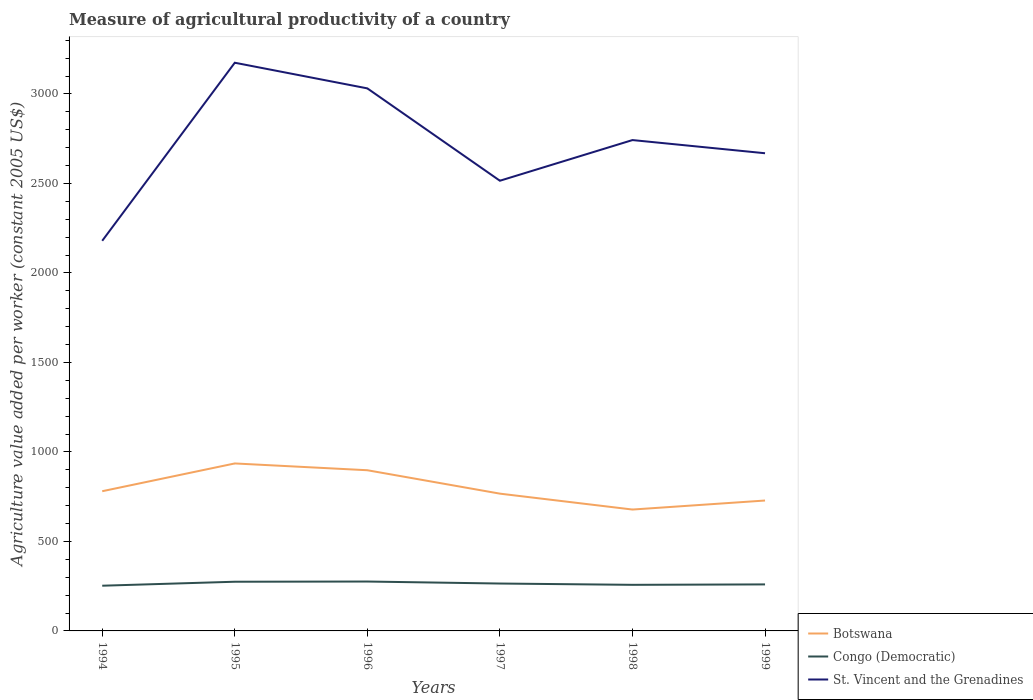Across all years, what is the maximum measure of agricultural productivity in St. Vincent and the Grenadines?
Your answer should be very brief. 2179.39. In which year was the measure of agricultural productivity in St. Vincent and the Grenadines maximum?
Keep it short and to the point. 1994. What is the total measure of agricultural productivity in St. Vincent and the Grenadines in the graph?
Your response must be concise. 288.8. What is the difference between the highest and the second highest measure of agricultural productivity in St. Vincent and the Grenadines?
Provide a short and direct response. 994.81. How many years are there in the graph?
Keep it short and to the point. 6. Does the graph contain grids?
Offer a terse response. No. How are the legend labels stacked?
Keep it short and to the point. Vertical. What is the title of the graph?
Your response must be concise. Measure of agricultural productivity of a country. What is the label or title of the X-axis?
Ensure brevity in your answer.  Years. What is the label or title of the Y-axis?
Make the answer very short. Agriculture value added per worker (constant 2005 US$). What is the Agriculture value added per worker (constant 2005 US$) of Botswana in 1994?
Your answer should be compact. 780.43. What is the Agriculture value added per worker (constant 2005 US$) of Congo (Democratic) in 1994?
Offer a very short reply. 252.57. What is the Agriculture value added per worker (constant 2005 US$) in St. Vincent and the Grenadines in 1994?
Provide a succinct answer. 2179.39. What is the Agriculture value added per worker (constant 2005 US$) of Botswana in 1995?
Ensure brevity in your answer.  935.6. What is the Agriculture value added per worker (constant 2005 US$) of Congo (Democratic) in 1995?
Your response must be concise. 274.79. What is the Agriculture value added per worker (constant 2005 US$) of St. Vincent and the Grenadines in 1995?
Your response must be concise. 3174.2. What is the Agriculture value added per worker (constant 2005 US$) of Botswana in 1996?
Offer a terse response. 897.7. What is the Agriculture value added per worker (constant 2005 US$) of Congo (Democratic) in 1996?
Provide a succinct answer. 275.92. What is the Agriculture value added per worker (constant 2005 US$) in St. Vincent and the Grenadines in 1996?
Your answer should be compact. 3030.91. What is the Agriculture value added per worker (constant 2005 US$) in Botswana in 1997?
Provide a short and direct response. 766.89. What is the Agriculture value added per worker (constant 2005 US$) in Congo (Democratic) in 1997?
Offer a very short reply. 264.74. What is the Agriculture value added per worker (constant 2005 US$) in St. Vincent and the Grenadines in 1997?
Your answer should be very brief. 2514.94. What is the Agriculture value added per worker (constant 2005 US$) of Botswana in 1998?
Offer a very short reply. 678.06. What is the Agriculture value added per worker (constant 2005 US$) of Congo (Democratic) in 1998?
Your answer should be very brief. 257.49. What is the Agriculture value added per worker (constant 2005 US$) in St. Vincent and the Grenadines in 1998?
Offer a very short reply. 2742.11. What is the Agriculture value added per worker (constant 2005 US$) of Botswana in 1999?
Offer a terse response. 728.46. What is the Agriculture value added per worker (constant 2005 US$) in Congo (Democratic) in 1999?
Your answer should be compact. 259.88. What is the Agriculture value added per worker (constant 2005 US$) in St. Vincent and the Grenadines in 1999?
Give a very brief answer. 2668.51. Across all years, what is the maximum Agriculture value added per worker (constant 2005 US$) of Botswana?
Your response must be concise. 935.6. Across all years, what is the maximum Agriculture value added per worker (constant 2005 US$) of Congo (Democratic)?
Your answer should be compact. 275.92. Across all years, what is the maximum Agriculture value added per worker (constant 2005 US$) in St. Vincent and the Grenadines?
Offer a terse response. 3174.2. Across all years, what is the minimum Agriculture value added per worker (constant 2005 US$) of Botswana?
Make the answer very short. 678.06. Across all years, what is the minimum Agriculture value added per worker (constant 2005 US$) in Congo (Democratic)?
Provide a short and direct response. 252.57. Across all years, what is the minimum Agriculture value added per worker (constant 2005 US$) of St. Vincent and the Grenadines?
Offer a terse response. 2179.39. What is the total Agriculture value added per worker (constant 2005 US$) in Botswana in the graph?
Your answer should be very brief. 4787.14. What is the total Agriculture value added per worker (constant 2005 US$) in Congo (Democratic) in the graph?
Give a very brief answer. 1585.38. What is the total Agriculture value added per worker (constant 2005 US$) in St. Vincent and the Grenadines in the graph?
Provide a short and direct response. 1.63e+04. What is the difference between the Agriculture value added per worker (constant 2005 US$) in Botswana in 1994 and that in 1995?
Give a very brief answer. -155.17. What is the difference between the Agriculture value added per worker (constant 2005 US$) of Congo (Democratic) in 1994 and that in 1995?
Your answer should be compact. -22.22. What is the difference between the Agriculture value added per worker (constant 2005 US$) of St. Vincent and the Grenadines in 1994 and that in 1995?
Offer a very short reply. -994.81. What is the difference between the Agriculture value added per worker (constant 2005 US$) in Botswana in 1994 and that in 1996?
Your answer should be very brief. -117.27. What is the difference between the Agriculture value added per worker (constant 2005 US$) of Congo (Democratic) in 1994 and that in 1996?
Give a very brief answer. -23.36. What is the difference between the Agriculture value added per worker (constant 2005 US$) in St. Vincent and the Grenadines in 1994 and that in 1996?
Make the answer very short. -851.51. What is the difference between the Agriculture value added per worker (constant 2005 US$) of Botswana in 1994 and that in 1997?
Provide a succinct answer. 13.53. What is the difference between the Agriculture value added per worker (constant 2005 US$) of Congo (Democratic) in 1994 and that in 1997?
Offer a terse response. -12.17. What is the difference between the Agriculture value added per worker (constant 2005 US$) of St. Vincent and the Grenadines in 1994 and that in 1997?
Provide a succinct answer. -335.55. What is the difference between the Agriculture value added per worker (constant 2005 US$) of Botswana in 1994 and that in 1998?
Ensure brevity in your answer.  102.37. What is the difference between the Agriculture value added per worker (constant 2005 US$) in Congo (Democratic) in 1994 and that in 1998?
Your answer should be very brief. -4.93. What is the difference between the Agriculture value added per worker (constant 2005 US$) of St. Vincent and the Grenadines in 1994 and that in 1998?
Make the answer very short. -562.72. What is the difference between the Agriculture value added per worker (constant 2005 US$) of Botswana in 1994 and that in 1999?
Give a very brief answer. 51.97. What is the difference between the Agriculture value added per worker (constant 2005 US$) of Congo (Democratic) in 1994 and that in 1999?
Your answer should be very brief. -7.31. What is the difference between the Agriculture value added per worker (constant 2005 US$) in St. Vincent and the Grenadines in 1994 and that in 1999?
Make the answer very short. -489.12. What is the difference between the Agriculture value added per worker (constant 2005 US$) in Botswana in 1995 and that in 1996?
Make the answer very short. 37.91. What is the difference between the Agriculture value added per worker (constant 2005 US$) of Congo (Democratic) in 1995 and that in 1996?
Provide a succinct answer. -1.14. What is the difference between the Agriculture value added per worker (constant 2005 US$) in St. Vincent and the Grenadines in 1995 and that in 1996?
Offer a very short reply. 143.3. What is the difference between the Agriculture value added per worker (constant 2005 US$) of Botswana in 1995 and that in 1997?
Your answer should be very brief. 168.71. What is the difference between the Agriculture value added per worker (constant 2005 US$) in Congo (Democratic) in 1995 and that in 1997?
Your answer should be very brief. 10.05. What is the difference between the Agriculture value added per worker (constant 2005 US$) in St. Vincent and the Grenadines in 1995 and that in 1997?
Offer a very short reply. 659.26. What is the difference between the Agriculture value added per worker (constant 2005 US$) of Botswana in 1995 and that in 1998?
Your answer should be very brief. 257.54. What is the difference between the Agriculture value added per worker (constant 2005 US$) of Congo (Democratic) in 1995 and that in 1998?
Provide a succinct answer. 17.29. What is the difference between the Agriculture value added per worker (constant 2005 US$) of St. Vincent and the Grenadines in 1995 and that in 1998?
Ensure brevity in your answer.  432.09. What is the difference between the Agriculture value added per worker (constant 2005 US$) in Botswana in 1995 and that in 1999?
Your answer should be very brief. 207.14. What is the difference between the Agriculture value added per worker (constant 2005 US$) in Congo (Democratic) in 1995 and that in 1999?
Your answer should be very brief. 14.91. What is the difference between the Agriculture value added per worker (constant 2005 US$) in St. Vincent and the Grenadines in 1995 and that in 1999?
Offer a terse response. 505.69. What is the difference between the Agriculture value added per worker (constant 2005 US$) of Botswana in 1996 and that in 1997?
Offer a terse response. 130.8. What is the difference between the Agriculture value added per worker (constant 2005 US$) of Congo (Democratic) in 1996 and that in 1997?
Give a very brief answer. 11.19. What is the difference between the Agriculture value added per worker (constant 2005 US$) of St. Vincent and the Grenadines in 1996 and that in 1997?
Your answer should be very brief. 515.96. What is the difference between the Agriculture value added per worker (constant 2005 US$) of Botswana in 1996 and that in 1998?
Ensure brevity in your answer.  219.64. What is the difference between the Agriculture value added per worker (constant 2005 US$) in Congo (Democratic) in 1996 and that in 1998?
Your answer should be very brief. 18.43. What is the difference between the Agriculture value added per worker (constant 2005 US$) of St. Vincent and the Grenadines in 1996 and that in 1998?
Offer a very short reply. 288.8. What is the difference between the Agriculture value added per worker (constant 2005 US$) in Botswana in 1996 and that in 1999?
Give a very brief answer. 169.24. What is the difference between the Agriculture value added per worker (constant 2005 US$) in Congo (Democratic) in 1996 and that in 1999?
Keep it short and to the point. 16.05. What is the difference between the Agriculture value added per worker (constant 2005 US$) in St. Vincent and the Grenadines in 1996 and that in 1999?
Your answer should be compact. 362.4. What is the difference between the Agriculture value added per worker (constant 2005 US$) in Botswana in 1997 and that in 1998?
Your answer should be very brief. 88.83. What is the difference between the Agriculture value added per worker (constant 2005 US$) of Congo (Democratic) in 1997 and that in 1998?
Ensure brevity in your answer.  7.24. What is the difference between the Agriculture value added per worker (constant 2005 US$) in St. Vincent and the Grenadines in 1997 and that in 1998?
Offer a terse response. -227.17. What is the difference between the Agriculture value added per worker (constant 2005 US$) of Botswana in 1997 and that in 1999?
Your answer should be very brief. 38.44. What is the difference between the Agriculture value added per worker (constant 2005 US$) in Congo (Democratic) in 1997 and that in 1999?
Your answer should be very brief. 4.86. What is the difference between the Agriculture value added per worker (constant 2005 US$) of St. Vincent and the Grenadines in 1997 and that in 1999?
Offer a terse response. -153.57. What is the difference between the Agriculture value added per worker (constant 2005 US$) in Botswana in 1998 and that in 1999?
Give a very brief answer. -50.4. What is the difference between the Agriculture value added per worker (constant 2005 US$) of Congo (Democratic) in 1998 and that in 1999?
Provide a succinct answer. -2.38. What is the difference between the Agriculture value added per worker (constant 2005 US$) in St. Vincent and the Grenadines in 1998 and that in 1999?
Offer a terse response. 73.6. What is the difference between the Agriculture value added per worker (constant 2005 US$) in Botswana in 1994 and the Agriculture value added per worker (constant 2005 US$) in Congo (Democratic) in 1995?
Your answer should be very brief. 505.64. What is the difference between the Agriculture value added per worker (constant 2005 US$) of Botswana in 1994 and the Agriculture value added per worker (constant 2005 US$) of St. Vincent and the Grenadines in 1995?
Your response must be concise. -2393.77. What is the difference between the Agriculture value added per worker (constant 2005 US$) in Congo (Democratic) in 1994 and the Agriculture value added per worker (constant 2005 US$) in St. Vincent and the Grenadines in 1995?
Offer a terse response. -2921.63. What is the difference between the Agriculture value added per worker (constant 2005 US$) in Botswana in 1994 and the Agriculture value added per worker (constant 2005 US$) in Congo (Democratic) in 1996?
Your answer should be very brief. 504.51. What is the difference between the Agriculture value added per worker (constant 2005 US$) of Botswana in 1994 and the Agriculture value added per worker (constant 2005 US$) of St. Vincent and the Grenadines in 1996?
Offer a very short reply. -2250.48. What is the difference between the Agriculture value added per worker (constant 2005 US$) of Congo (Democratic) in 1994 and the Agriculture value added per worker (constant 2005 US$) of St. Vincent and the Grenadines in 1996?
Provide a short and direct response. -2778.34. What is the difference between the Agriculture value added per worker (constant 2005 US$) in Botswana in 1994 and the Agriculture value added per worker (constant 2005 US$) in Congo (Democratic) in 1997?
Offer a terse response. 515.69. What is the difference between the Agriculture value added per worker (constant 2005 US$) of Botswana in 1994 and the Agriculture value added per worker (constant 2005 US$) of St. Vincent and the Grenadines in 1997?
Keep it short and to the point. -1734.51. What is the difference between the Agriculture value added per worker (constant 2005 US$) of Congo (Democratic) in 1994 and the Agriculture value added per worker (constant 2005 US$) of St. Vincent and the Grenadines in 1997?
Your answer should be compact. -2262.38. What is the difference between the Agriculture value added per worker (constant 2005 US$) in Botswana in 1994 and the Agriculture value added per worker (constant 2005 US$) in Congo (Democratic) in 1998?
Provide a succinct answer. 522.94. What is the difference between the Agriculture value added per worker (constant 2005 US$) in Botswana in 1994 and the Agriculture value added per worker (constant 2005 US$) in St. Vincent and the Grenadines in 1998?
Offer a terse response. -1961.68. What is the difference between the Agriculture value added per worker (constant 2005 US$) of Congo (Democratic) in 1994 and the Agriculture value added per worker (constant 2005 US$) of St. Vincent and the Grenadines in 1998?
Your response must be concise. -2489.54. What is the difference between the Agriculture value added per worker (constant 2005 US$) of Botswana in 1994 and the Agriculture value added per worker (constant 2005 US$) of Congo (Democratic) in 1999?
Offer a terse response. 520.55. What is the difference between the Agriculture value added per worker (constant 2005 US$) in Botswana in 1994 and the Agriculture value added per worker (constant 2005 US$) in St. Vincent and the Grenadines in 1999?
Give a very brief answer. -1888.08. What is the difference between the Agriculture value added per worker (constant 2005 US$) of Congo (Democratic) in 1994 and the Agriculture value added per worker (constant 2005 US$) of St. Vincent and the Grenadines in 1999?
Your answer should be compact. -2415.94. What is the difference between the Agriculture value added per worker (constant 2005 US$) of Botswana in 1995 and the Agriculture value added per worker (constant 2005 US$) of Congo (Democratic) in 1996?
Your response must be concise. 659.68. What is the difference between the Agriculture value added per worker (constant 2005 US$) of Botswana in 1995 and the Agriculture value added per worker (constant 2005 US$) of St. Vincent and the Grenadines in 1996?
Offer a terse response. -2095.3. What is the difference between the Agriculture value added per worker (constant 2005 US$) of Congo (Democratic) in 1995 and the Agriculture value added per worker (constant 2005 US$) of St. Vincent and the Grenadines in 1996?
Ensure brevity in your answer.  -2756.12. What is the difference between the Agriculture value added per worker (constant 2005 US$) of Botswana in 1995 and the Agriculture value added per worker (constant 2005 US$) of Congo (Democratic) in 1997?
Offer a terse response. 670.87. What is the difference between the Agriculture value added per worker (constant 2005 US$) in Botswana in 1995 and the Agriculture value added per worker (constant 2005 US$) in St. Vincent and the Grenadines in 1997?
Keep it short and to the point. -1579.34. What is the difference between the Agriculture value added per worker (constant 2005 US$) of Congo (Democratic) in 1995 and the Agriculture value added per worker (constant 2005 US$) of St. Vincent and the Grenadines in 1997?
Ensure brevity in your answer.  -2240.16. What is the difference between the Agriculture value added per worker (constant 2005 US$) of Botswana in 1995 and the Agriculture value added per worker (constant 2005 US$) of Congo (Democratic) in 1998?
Your response must be concise. 678.11. What is the difference between the Agriculture value added per worker (constant 2005 US$) of Botswana in 1995 and the Agriculture value added per worker (constant 2005 US$) of St. Vincent and the Grenadines in 1998?
Your answer should be very brief. -1806.51. What is the difference between the Agriculture value added per worker (constant 2005 US$) in Congo (Democratic) in 1995 and the Agriculture value added per worker (constant 2005 US$) in St. Vincent and the Grenadines in 1998?
Your answer should be very brief. -2467.32. What is the difference between the Agriculture value added per worker (constant 2005 US$) of Botswana in 1995 and the Agriculture value added per worker (constant 2005 US$) of Congo (Democratic) in 1999?
Offer a terse response. 675.73. What is the difference between the Agriculture value added per worker (constant 2005 US$) of Botswana in 1995 and the Agriculture value added per worker (constant 2005 US$) of St. Vincent and the Grenadines in 1999?
Ensure brevity in your answer.  -1732.91. What is the difference between the Agriculture value added per worker (constant 2005 US$) of Congo (Democratic) in 1995 and the Agriculture value added per worker (constant 2005 US$) of St. Vincent and the Grenadines in 1999?
Ensure brevity in your answer.  -2393.72. What is the difference between the Agriculture value added per worker (constant 2005 US$) of Botswana in 1996 and the Agriculture value added per worker (constant 2005 US$) of Congo (Democratic) in 1997?
Keep it short and to the point. 632.96. What is the difference between the Agriculture value added per worker (constant 2005 US$) of Botswana in 1996 and the Agriculture value added per worker (constant 2005 US$) of St. Vincent and the Grenadines in 1997?
Your answer should be very brief. -1617.25. What is the difference between the Agriculture value added per worker (constant 2005 US$) of Congo (Democratic) in 1996 and the Agriculture value added per worker (constant 2005 US$) of St. Vincent and the Grenadines in 1997?
Give a very brief answer. -2239.02. What is the difference between the Agriculture value added per worker (constant 2005 US$) in Botswana in 1996 and the Agriculture value added per worker (constant 2005 US$) in Congo (Democratic) in 1998?
Give a very brief answer. 640.2. What is the difference between the Agriculture value added per worker (constant 2005 US$) in Botswana in 1996 and the Agriculture value added per worker (constant 2005 US$) in St. Vincent and the Grenadines in 1998?
Your answer should be compact. -1844.41. What is the difference between the Agriculture value added per worker (constant 2005 US$) in Congo (Democratic) in 1996 and the Agriculture value added per worker (constant 2005 US$) in St. Vincent and the Grenadines in 1998?
Keep it short and to the point. -2466.19. What is the difference between the Agriculture value added per worker (constant 2005 US$) of Botswana in 1996 and the Agriculture value added per worker (constant 2005 US$) of Congo (Democratic) in 1999?
Keep it short and to the point. 637.82. What is the difference between the Agriculture value added per worker (constant 2005 US$) of Botswana in 1996 and the Agriculture value added per worker (constant 2005 US$) of St. Vincent and the Grenadines in 1999?
Your response must be concise. -1770.81. What is the difference between the Agriculture value added per worker (constant 2005 US$) of Congo (Democratic) in 1996 and the Agriculture value added per worker (constant 2005 US$) of St. Vincent and the Grenadines in 1999?
Offer a terse response. -2392.59. What is the difference between the Agriculture value added per worker (constant 2005 US$) in Botswana in 1997 and the Agriculture value added per worker (constant 2005 US$) in Congo (Democratic) in 1998?
Provide a succinct answer. 509.4. What is the difference between the Agriculture value added per worker (constant 2005 US$) of Botswana in 1997 and the Agriculture value added per worker (constant 2005 US$) of St. Vincent and the Grenadines in 1998?
Provide a short and direct response. -1975.22. What is the difference between the Agriculture value added per worker (constant 2005 US$) in Congo (Democratic) in 1997 and the Agriculture value added per worker (constant 2005 US$) in St. Vincent and the Grenadines in 1998?
Keep it short and to the point. -2477.37. What is the difference between the Agriculture value added per worker (constant 2005 US$) of Botswana in 1997 and the Agriculture value added per worker (constant 2005 US$) of Congo (Democratic) in 1999?
Provide a succinct answer. 507.02. What is the difference between the Agriculture value added per worker (constant 2005 US$) of Botswana in 1997 and the Agriculture value added per worker (constant 2005 US$) of St. Vincent and the Grenadines in 1999?
Offer a terse response. -1901.62. What is the difference between the Agriculture value added per worker (constant 2005 US$) of Congo (Democratic) in 1997 and the Agriculture value added per worker (constant 2005 US$) of St. Vincent and the Grenadines in 1999?
Your answer should be very brief. -2403.77. What is the difference between the Agriculture value added per worker (constant 2005 US$) of Botswana in 1998 and the Agriculture value added per worker (constant 2005 US$) of Congo (Democratic) in 1999?
Your response must be concise. 418.19. What is the difference between the Agriculture value added per worker (constant 2005 US$) in Botswana in 1998 and the Agriculture value added per worker (constant 2005 US$) in St. Vincent and the Grenadines in 1999?
Your answer should be compact. -1990.45. What is the difference between the Agriculture value added per worker (constant 2005 US$) of Congo (Democratic) in 1998 and the Agriculture value added per worker (constant 2005 US$) of St. Vincent and the Grenadines in 1999?
Ensure brevity in your answer.  -2411.02. What is the average Agriculture value added per worker (constant 2005 US$) of Botswana per year?
Your response must be concise. 797.86. What is the average Agriculture value added per worker (constant 2005 US$) of Congo (Democratic) per year?
Give a very brief answer. 264.23. What is the average Agriculture value added per worker (constant 2005 US$) of St. Vincent and the Grenadines per year?
Provide a short and direct response. 2718.34. In the year 1994, what is the difference between the Agriculture value added per worker (constant 2005 US$) of Botswana and Agriculture value added per worker (constant 2005 US$) of Congo (Democratic)?
Ensure brevity in your answer.  527.86. In the year 1994, what is the difference between the Agriculture value added per worker (constant 2005 US$) in Botswana and Agriculture value added per worker (constant 2005 US$) in St. Vincent and the Grenadines?
Make the answer very short. -1398.96. In the year 1994, what is the difference between the Agriculture value added per worker (constant 2005 US$) in Congo (Democratic) and Agriculture value added per worker (constant 2005 US$) in St. Vincent and the Grenadines?
Offer a very short reply. -1926.82. In the year 1995, what is the difference between the Agriculture value added per worker (constant 2005 US$) of Botswana and Agriculture value added per worker (constant 2005 US$) of Congo (Democratic)?
Give a very brief answer. 660.81. In the year 1995, what is the difference between the Agriculture value added per worker (constant 2005 US$) in Botswana and Agriculture value added per worker (constant 2005 US$) in St. Vincent and the Grenadines?
Your response must be concise. -2238.6. In the year 1995, what is the difference between the Agriculture value added per worker (constant 2005 US$) of Congo (Democratic) and Agriculture value added per worker (constant 2005 US$) of St. Vincent and the Grenadines?
Your answer should be very brief. -2899.41. In the year 1996, what is the difference between the Agriculture value added per worker (constant 2005 US$) in Botswana and Agriculture value added per worker (constant 2005 US$) in Congo (Democratic)?
Ensure brevity in your answer.  621.77. In the year 1996, what is the difference between the Agriculture value added per worker (constant 2005 US$) of Botswana and Agriculture value added per worker (constant 2005 US$) of St. Vincent and the Grenadines?
Provide a short and direct response. -2133.21. In the year 1996, what is the difference between the Agriculture value added per worker (constant 2005 US$) in Congo (Democratic) and Agriculture value added per worker (constant 2005 US$) in St. Vincent and the Grenadines?
Offer a very short reply. -2754.98. In the year 1997, what is the difference between the Agriculture value added per worker (constant 2005 US$) in Botswana and Agriculture value added per worker (constant 2005 US$) in Congo (Democratic)?
Your answer should be very brief. 502.16. In the year 1997, what is the difference between the Agriculture value added per worker (constant 2005 US$) in Botswana and Agriculture value added per worker (constant 2005 US$) in St. Vincent and the Grenadines?
Offer a very short reply. -1748.05. In the year 1997, what is the difference between the Agriculture value added per worker (constant 2005 US$) in Congo (Democratic) and Agriculture value added per worker (constant 2005 US$) in St. Vincent and the Grenadines?
Provide a short and direct response. -2250.21. In the year 1998, what is the difference between the Agriculture value added per worker (constant 2005 US$) of Botswana and Agriculture value added per worker (constant 2005 US$) of Congo (Democratic)?
Offer a very short reply. 420.57. In the year 1998, what is the difference between the Agriculture value added per worker (constant 2005 US$) in Botswana and Agriculture value added per worker (constant 2005 US$) in St. Vincent and the Grenadines?
Provide a succinct answer. -2064.05. In the year 1998, what is the difference between the Agriculture value added per worker (constant 2005 US$) of Congo (Democratic) and Agriculture value added per worker (constant 2005 US$) of St. Vincent and the Grenadines?
Keep it short and to the point. -2484.62. In the year 1999, what is the difference between the Agriculture value added per worker (constant 2005 US$) in Botswana and Agriculture value added per worker (constant 2005 US$) in Congo (Democratic)?
Your answer should be compact. 468.58. In the year 1999, what is the difference between the Agriculture value added per worker (constant 2005 US$) in Botswana and Agriculture value added per worker (constant 2005 US$) in St. Vincent and the Grenadines?
Give a very brief answer. -1940.05. In the year 1999, what is the difference between the Agriculture value added per worker (constant 2005 US$) in Congo (Democratic) and Agriculture value added per worker (constant 2005 US$) in St. Vincent and the Grenadines?
Make the answer very short. -2408.63. What is the ratio of the Agriculture value added per worker (constant 2005 US$) of Botswana in 1994 to that in 1995?
Give a very brief answer. 0.83. What is the ratio of the Agriculture value added per worker (constant 2005 US$) in Congo (Democratic) in 1994 to that in 1995?
Offer a very short reply. 0.92. What is the ratio of the Agriculture value added per worker (constant 2005 US$) in St. Vincent and the Grenadines in 1994 to that in 1995?
Offer a terse response. 0.69. What is the ratio of the Agriculture value added per worker (constant 2005 US$) of Botswana in 1994 to that in 1996?
Offer a terse response. 0.87. What is the ratio of the Agriculture value added per worker (constant 2005 US$) in Congo (Democratic) in 1994 to that in 1996?
Give a very brief answer. 0.92. What is the ratio of the Agriculture value added per worker (constant 2005 US$) in St. Vincent and the Grenadines in 1994 to that in 1996?
Provide a succinct answer. 0.72. What is the ratio of the Agriculture value added per worker (constant 2005 US$) in Botswana in 1994 to that in 1997?
Provide a short and direct response. 1.02. What is the ratio of the Agriculture value added per worker (constant 2005 US$) of Congo (Democratic) in 1994 to that in 1997?
Keep it short and to the point. 0.95. What is the ratio of the Agriculture value added per worker (constant 2005 US$) of St. Vincent and the Grenadines in 1994 to that in 1997?
Provide a succinct answer. 0.87. What is the ratio of the Agriculture value added per worker (constant 2005 US$) in Botswana in 1994 to that in 1998?
Your response must be concise. 1.15. What is the ratio of the Agriculture value added per worker (constant 2005 US$) of Congo (Democratic) in 1994 to that in 1998?
Offer a terse response. 0.98. What is the ratio of the Agriculture value added per worker (constant 2005 US$) in St. Vincent and the Grenadines in 1994 to that in 1998?
Your answer should be very brief. 0.79. What is the ratio of the Agriculture value added per worker (constant 2005 US$) of Botswana in 1994 to that in 1999?
Offer a terse response. 1.07. What is the ratio of the Agriculture value added per worker (constant 2005 US$) of Congo (Democratic) in 1994 to that in 1999?
Ensure brevity in your answer.  0.97. What is the ratio of the Agriculture value added per worker (constant 2005 US$) of St. Vincent and the Grenadines in 1994 to that in 1999?
Your answer should be very brief. 0.82. What is the ratio of the Agriculture value added per worker (constant 2005 US$) in Botswana in 1995 to that in 1996?
Your answer should be very brief. 1.04. What is the ratio of the Agriculture value added per worker (constant 2005 US$) in Congo (Democratic) in 1995 to that in 1996?
Keep it short and to the point. 1. What is the ratio of the Agriculture value added per worker (constant 2005 US$) of St. Vincent and the Grenadines in 1995 to that in 1996?
Offer a terse response. 1.05. What is the ratio of the Agriculture value added per worker (constant 2005 US$) in Botswana in 1995 to that in 1997?
Your answer should be compact. 1.22. What is the ratio of the Agriculture value added per worker (constant 2005 US$) of Congo (Democratic) in 1995 to that in 1997?
Ensure brevity in your answer.  1.04. What is the ratio of the Agriculture value added per worker (constant 2005 US$) in St. Vincent and the Grenadines in 1995 to that in 1997?
Offer a terse response. 1.26. What is the ratio of the Agriculture value added per worker (constant 2005 US$) of Botswana in 1995 to that in 1998?
Your answer should be compact. 1.38. What is the ratio of the Agriculture value added per worker (constant 2005 US$) of Congo (Democratic) in 1995 to that in 1998?
Provide a succinct answer. 1.07. What is the ratio of the Agriculture value added per worker (constant 2005 US$) in St. Vincent and the Grenadines in 1995 to that in 1998?
Your response must be concise. 1.16. What is the ratio of the Agriculture value added per worker (constant 2005 US$) in Botswana in 1995 to that in 1999?
Your answer should be compact. 1.28. What is the ratio of the Agriculture value added per worker (constant 2005 US$) in Congo (Democratic) in 1995 to that in 1999?
Make the answer very short. 1.06. What is the ratio of the Agriculture value added per worker (constant 2005 US$) of St. Vincent and the Grenadines in 1995 to that in 1999?
Ensure brevity in your answer.  1.19. What is the ratio of the Agriculture value added per worker (constant 2005 US$) in Botswana in 1996 to that in 1997?
Your response must be concise. 1.17. What is the ratio of the Agriculture value added per worker (constant 2005 US$) in Congo (Democratic) in 1996 to that in 1997?
Your answer should be compact. 1.04. What is the ratio of the Agriculture value added per worker (constant 2005 US$) of St. Vincent and the Grenadines in 1996 to that in 1997?
Provide a short and direct response. 1.21. What is the ratio of the Agriculture value added per worker (constant 2005 US$) in Botswana in 1996 to that in 1998?
Your answer should be very brief. 1.32. What is the ratio of the Agriculture value added per worker (constant 2005 US$) of Congo (Democratic) in 1996 to that in 1998?
Make the answer very short. 1.07. What is the ratio of the Agriculture value added per worker (constant 2005 US$) in St. Vincent and the Grenadines in 1996 to that in 1998?
Provide a succinct answer. 1.11. What is the ratio of the Agriculture value added per worker (constant 2005 US$) in Botswana in 1996 to that in 1999?
Your response must be concise. 1.23. What is the ratio of the Agriculture value added per worker (constant 2005 US$) in Congo (Democratic) in 1996 to that in 1999?
Make the answer very short. 1.06. What is the ratio of the Agriculture value added per worker (constant 2005 US$) in St. Vincent and the Grenadines in 1996 to that in 1999?
Provide a short and direct response. 1.14. What is the ratio of the Agriculture value added per worker (constant 2005 US$) of Botswana in 1997 to that in 1998?
Offer a very short reply. 1.13. What is the ratio of the Agriculture value added per worker (constant 2005 US$) of Congo (Democratic) in 1997 to that in 1998?
Give a very brief answer. 1.03. What is the ratio of the Agriculture value added per worker (constant 2005 US$) of St. Vincent and the Grenadines in 1997 to that in 1998?
Provide a short and direct response. 0.92. What is the ratio of the Agriculture value added per worker (constant 2005 US$) of Botswana in 1997 to that in 1999?
Keep it short and to the point. 1.05. What is the ratio of the Agriculture value added per worker (constant 2005 US$) in Congo (Democratic) in 1997 to that in 1999?
Offer a very short reply. 1.02. What is the ratio of the Agriculture value added per worker (constant 2005 US$) in St. Vincent and the Grenadines in 1997 to that in 1999?
Provide a succinct answer. 0.94. What is the ratio of the Agriculture value added per worker (constant 2005 US$) in Botswana in 1998 to that in 1999?
Give a very brief answer. 0.93. What is the ratio of the Agriculture value added per worker (constant 2005 US$) of St. Vincent and the Grenadines in 1998 to that in 1999?
Offer a terse response. 1.03. What is the difference between the highest and the second highest Agriculture value added per worker (constant 2005 US$) in Botswana?
Provide a short and direct response. 37.91. What is the difference between the highest and the second highest Agriculture value added per worker (constant 2005 US$) in Congo (Democratic)?
Provide a short and direct response. 1.14. What is the difference between the highest and the second highest Agriculture value added per worker (constant 2005 US$) of St. Vincent and the Grenadines?
Provide a short and direct response. 143.3. What is the difference between the highest and the lowest Agriculture value added per worker (constant 2005 US$) of Botswana?
Your response must be concise. 257.54. What is the difference between the highest and the lowest Agriculture value added per worker (constant 2005 US$) of Congo (Democratic)?
Your response must be concise. 23.36. What is the difference between the highest and the lowest Agriculture value added per worker (constant 2005 US$) of St. Vincent and the Grenadines?
Provide a short and direct response. 994.81. 